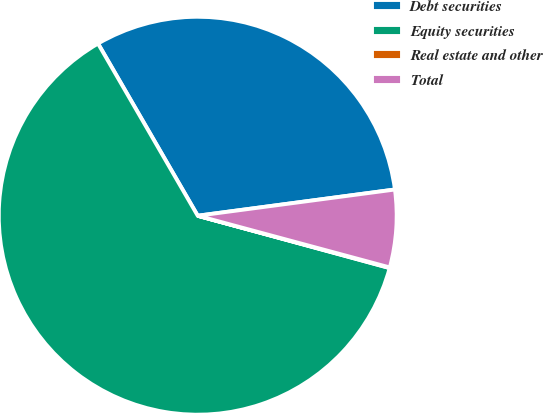Convert chart. <chart><loc_0><loc_0><loc_500><loc_500><pie_chart><fcel>Debt securities<fcel>Equity securities<fcel>Real estate and other<fcel>Total<nl><fcel>31.25%<fcel>62.41%<fcel>0.05%<fcel>6.29%<nl></chart> 